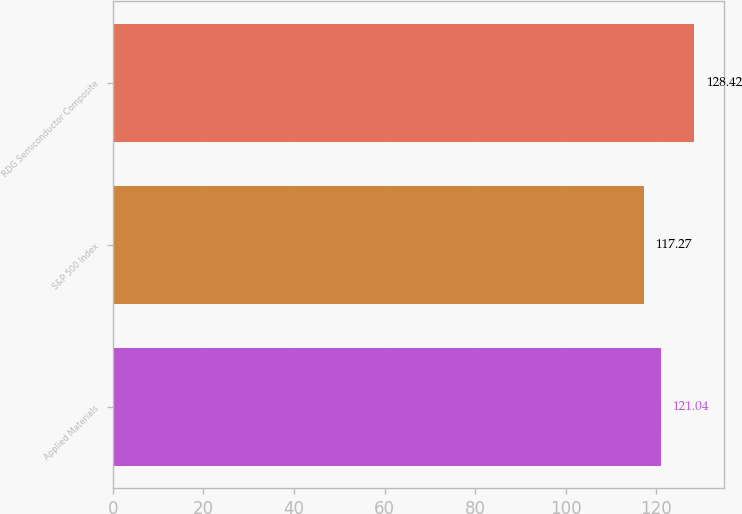<chart> <loc_0><loc_0><loc_500><loc_500><bar_chart><fcel>Applied Materials<fcel>S&P 500 Index<fcel>RDG Semiconductor Composite<nl><fcel>121.04<fcel>117.27<fcel>128.42<nl></chart> 